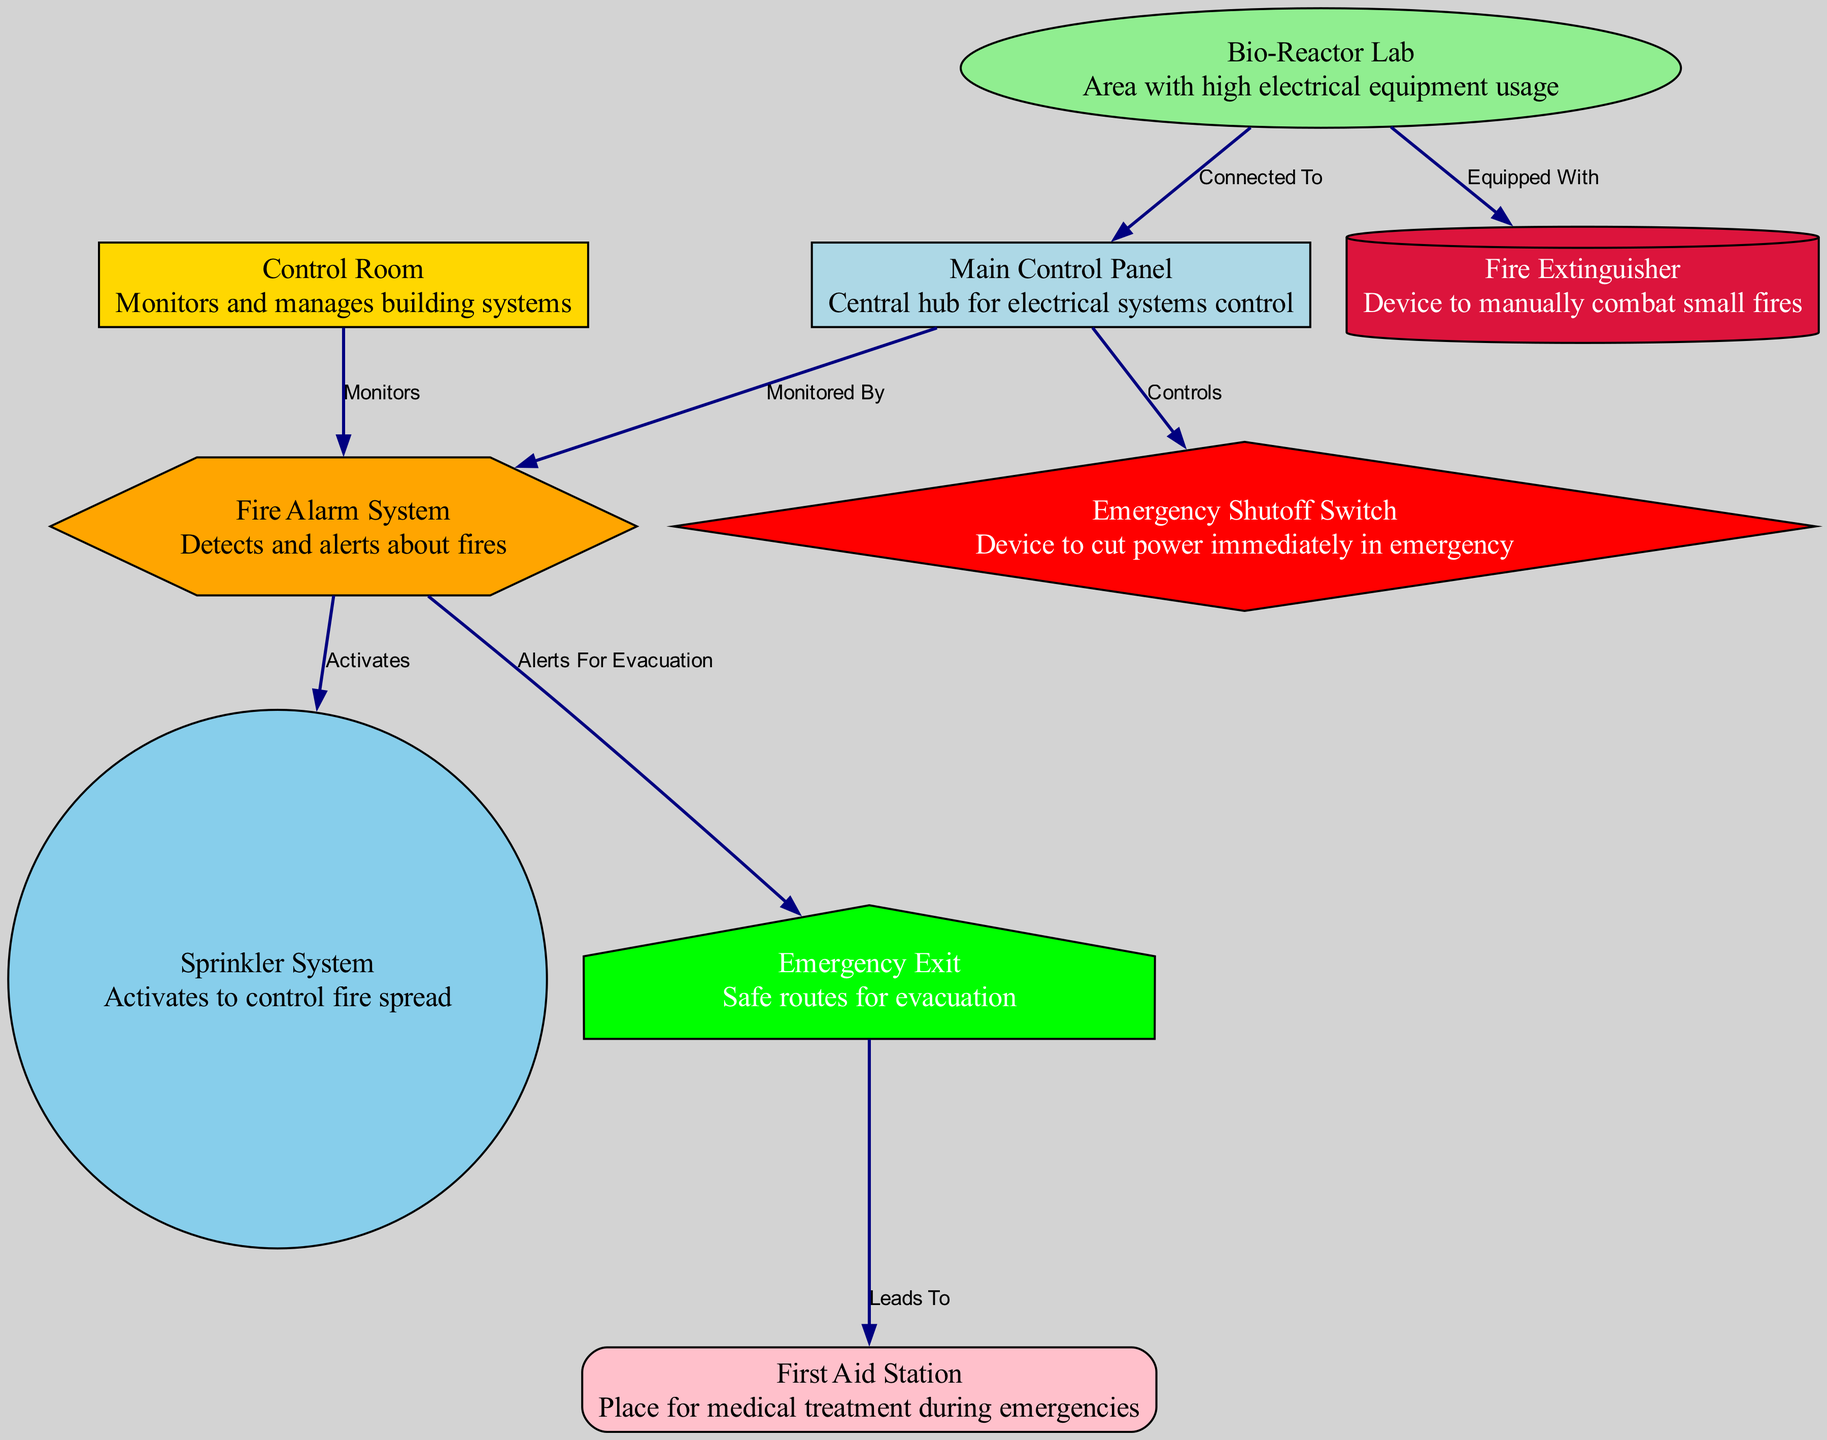What is the central hub for electrical systems control? The diagram indicates that the "Main Control Panel" serves as the central hub for controlling the building's electrical systems. This is directly identified in the node labeled "Main Control Panel."
Answer: Main Control Panel What device is used to cut power immediately in an emergency? According to the diagram, the "Emergency Shutoff Switch" is indicated as the device for cutting power in emergency situations. This can be found in the node labeled "Emergency Shutoff Switch."
Answer: Emergency Shutoff Switch How many nodes are present in the diagram? The diagram contains a total of 9 nodes representing different components relevant to emergency response in electrical fires.
Answer: 9 Which system activates the sprinkler system? The diagram shows that the "Fire Alarm System" is the one that activates the "Sprinkler System." This relationship is depicted in the respective edges connecting these nodes.
Answer: Fire Alarm System What is the relationship between the Bio-Reactor Lab and the Main Control Panel? The diagram indicates that the "Bio-Reactor Lab" is "Connected To" the "Main Control Panel," implying that it relies on the control panel for electrical management.
Answer: Connected To Which route leads to the First Aid Station during an emergency? The diagram shows that the "Emergency Exit" leads to the "First Aid Station," indicating that individuals use this route for medical treatment during emergencies. This is captured in the edge labeled "Leads To."
Answer: Leads To What role does the Control Room play in regards to the Fire Alarm System? The "Control Room" "Monitors" the "Fire Alarm System," as depicted in the edge connecting those two nodes. This shows that the Control Room oversees fire detection and alerts.
Answer: Monitors What equipment does the Bio-Reactor Lab have for small fires? Based on the information in the diagram, the "Bio-Reactor Lab" is "Equipped With" a "Fire Extinguisher," which indicates that this lab has the means to manually combat small fires.
Answer: Fire Extinguisher How does the Fire Alarm System facilitate evacuation? The diagram specifies that the "Fire Alarm System" "Alerts For Evacuation," indicating that it plays a crucial role in notifying occupants to evacuate in the event of a fire.
Answer: Alerts For Evacuation 